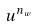Convert formula to latex. <formula><loc_0><loc_0><loc_500><loc_500>u ^ { n _ { w } }</formula> 